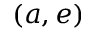<formula> <loc_0><loc_0><loc_500><loc_500>( a , e )</formula> 